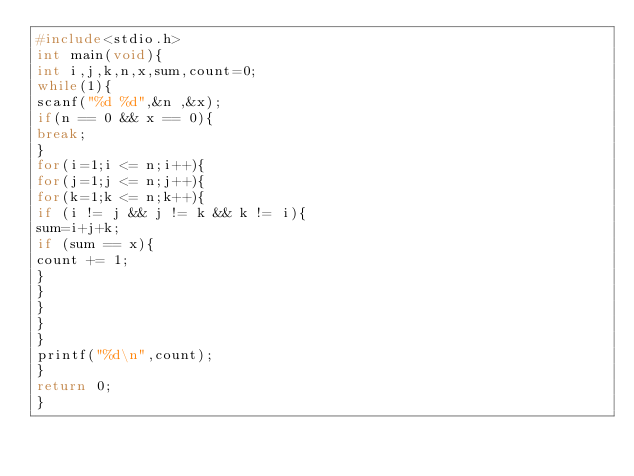Convert code to text. <code><loc_0><loc_0><loc_500><loc_500><_C_>#include<stdio.h>
int main(void){
int i,j,k,n,x,sum,count=0;
while(1){
scanf("%d %d",&n ,&x);
if(n == 0 && x == 0){
break;
}
for(i=1;i <= n;i++){
for(j=1;j <= n;j++){
for(k=1;k <= n;k++){
if (i != j && j != k && k != i){
sum=i+j+k;
if (sum == x){
count += 1;
}
}
}
}
}
printf("%d\n",count);
}
return 0;
}</code> 